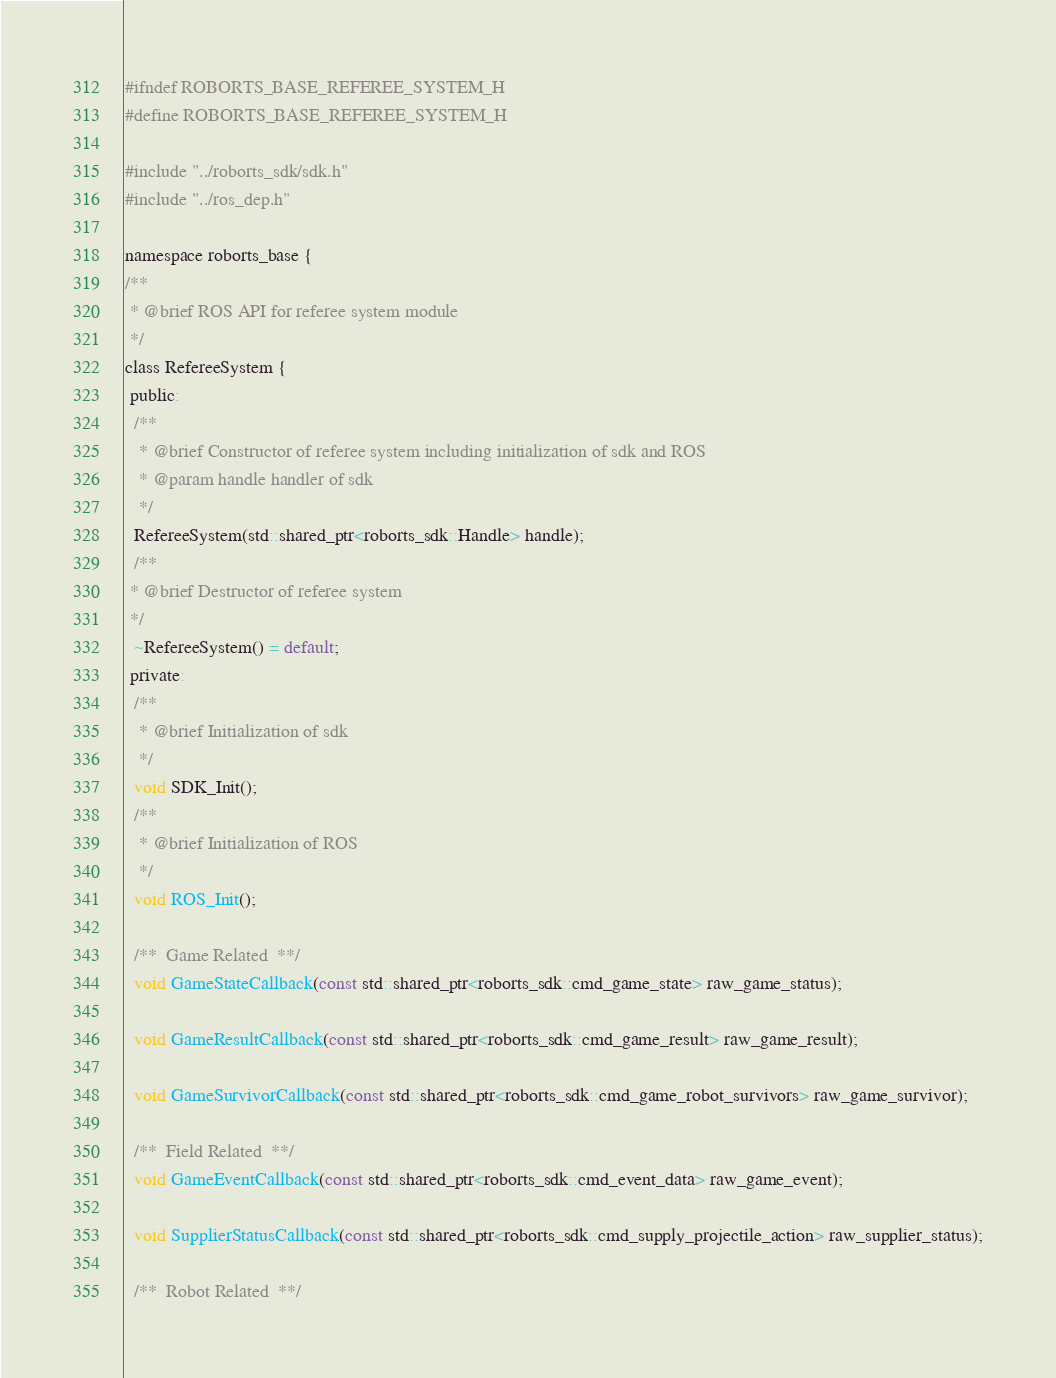Convert code to text. <code><loc_0><loc_0><loc_500><loc_500><_C_>#ifndef ROBORTS_BASE_REFEREE_SYSTEM_H
#define ROBORTS_BASE_REFEREE_SYSTEM_H

#include "../roborts_sdk/sdk.h"
#include "../ros_dep.h"

namespace roborts_base {
/**
 * @brief ROS API for referee system module
 */
class RefereeSystem {
 public:
  /**
   * @brief Constructor of referee system including initialization of sdk and ROS
   * @param handle handler of sdk
   */
  RefereeSystem(std::shared_ptr<roborts_sdk::Handle> handle);
  /**
 * @brief Destructor of referee system
 */
  ~RefereeSystem() = default;
 private:
  /**
   * @brief Initialization of sdk
   */
  void SDK_Init();
  /**
   * @brief Initialization of ROS
   */
  void ROS_Init();

  /**  Game Related  **/
  void GameStateCallback(const std::shared_ptr<roborts_sdk::cmd_game_state> raw_game_status);

  void GameResultCallback(const std::shared_ptr<roborts_sdk::cmd_game_result> raw_game_result);

  void GameSurvivorCallback(const std::shared_ptr<roborts_sdk::cmd_game_robot_survivors> raw_game_survivor);

  /**  Field Related  **/
  void GameEventCallback(const std::shared_ptr<roborts_sdk::cmd_event_data> raw_game_event);

  void SupplierStatusCallback(const std::shared_ptr<roborts_sdk::cmd_supply_projectile_action> raw_supplier_status);

  /**  Robot Related  **/</code> 